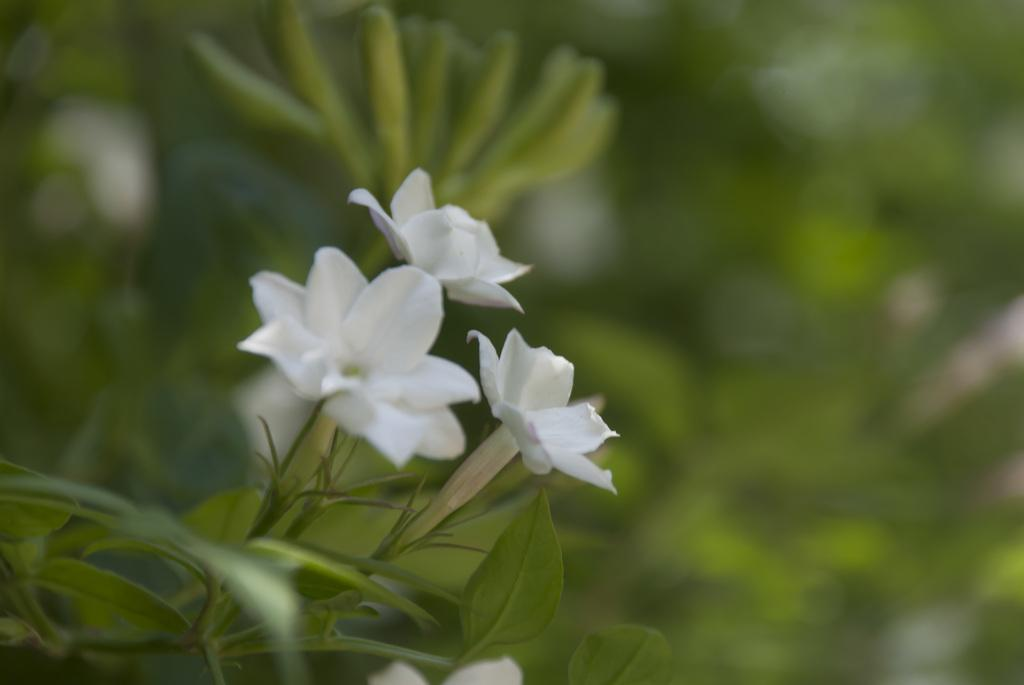What color are the flowers in the image? The flowers in the image are white. What can be seen in the background of the image? There are plants in green color in the background of the image. What type of cap is the person wearing in the image? There is no person or cap present in the image; it only features white flowers and green plants in the background. 